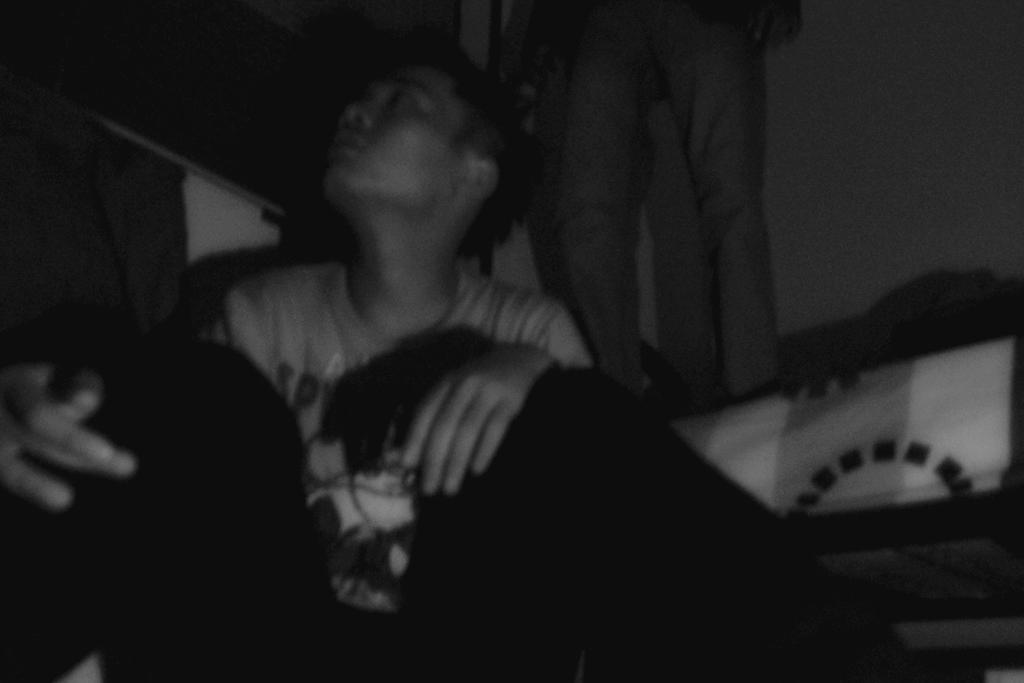Describe this image in one or two sentences. This is a black and white image and here we can see people sitting and standing and in the background, there is a wall and we can see a white color cloth. 